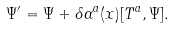Convert formula to latex. <formula><loc_0><loc_0><loc_500><loc_500>\Psi ^ { \prime } = \Psi + \delta \alpha ^ { a } ( x ) [ T ^ { a } , \Psi ] .</formula> 